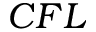Convert formula to latex. <formula><loc_0><loc_0><loc_500><loc_500>C F L</formula> 